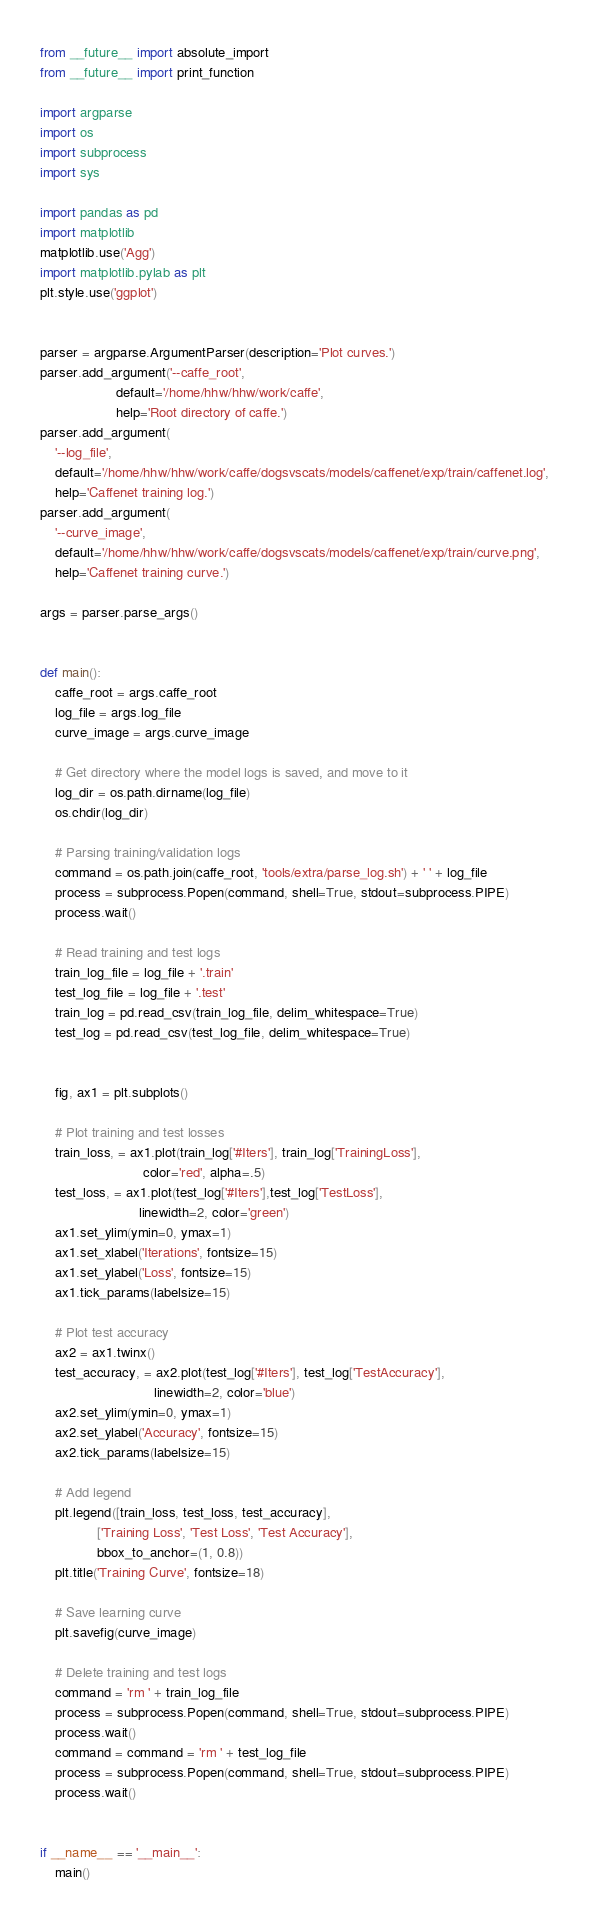Convert code to text. <code><loc_0><loc_0><loc_500><loc_500><_Python_>from __future__ import absolute_import
from __future__ import print_function

import argparse
import os
import subprocess
import sys

import pandas as pd
import matplotlib
matplotlib.use('Agg')
import matplotlib.pylab as plt
plt.style.use('ggplot')


parser = argparse.ArgumentParser(description='Plot curves.')
parser.add_argument('--caffe_root',
                    default='/home/hhw/hhw/work/caffe',
                    help='Root directory of caffe.')
parser.add_argument(
    '--log_file',
    default='/home/hhw/hhw/work/caffe/dogsvscats/models/caffenet/exp/train/caffenet.log',
    help='Caffenet training log.')
parser.add_argument(
    '--curve_image',
    default='/home/hhw/hhw/work/caffe/dogsvscats/models/caffenet/exp/train/curve.png',
    help='Caffenet training curve.')

args = parser.parse_args()


def main():
    caffe_root = args.caffe_root
    log_file = args.log_file
    curve_image = args.curve_image

    # Get directory where the model logs is saved, and move to it
    log_dir = os.path.dirname(log_file)
    os.chdir(log_dir)

    # Parsing training/validation logs
    command = os.path.join(caffe_root, 'tools/extra/parse_log.sh') + ' ' + log_file
    process = subprocess.Popen(command, shell=True, stdout=subprocess.PIPE)
    process.wait()

    # Read training and test logs
    train_log_file = log_file + '.train'
    test_log_file = log_file + '.test'
    train_log = pd.read_csv(train_log_file, delim_whitespace=True)
    test_log = pd.read_csv(test_log_file, delim_whitespace=True)


    fig, ax1 = plt.subplots()

    # Plot training and test losses
    train_loss, = ax1.plot(train_log['#Iters'], train_log['TrainingLoss'],
                           color='red', alpha=.5)
    test_loss, = ax1.plot(test_log['#Iters'],test_log['TestLoss'],
                          linewidth=2, color='green')
    ax1.set_ylim(ymin=0, ymax=1)
    ax1.set_xlabel('Iterations', fontsize=15)
    ax1.set_ylabel('Loss', fontsize=15)
    ax1.tick_params(labelsize=15)

    # Plot test accuracy
    ax2 = ax1.twinx()
    test_accuracy, = ax2.plot(test_log['#Iters'], test_log['TestAccuracy'],
                              linewidth=2, color='blue')
    ax2.set_ylim(ymin=0, ymax=1)
    ax2.set_ylabel('Accuracy', fontsize=15)
    ax2.tick_params(labelsize=15)

    # Add legend
    plt.legend([train_loss, test_loss, test_accuracy],
               ['Training Loss', 'Test Loss', 'Test Accuracy'],
               bbox_to_anchor=(1, 0.8))
    plt.title('Training Curve', fontsize=18)

    # Save learning curve
    plt.savefig(curve_image)

    # Delete training and test logs
    command = 'rm ' + train_log_file
    process = subprocess.Popen(command, shell=True, stdout=subprocess.PIPE)
    process.wait()
    command = command = 'rm ' + test_log_file
    process = subprocess.Popen(command, shell=True, stdout=subprocess.PIPE)
    process.wait()


if __name__ == '__main__':
    main()

</code> 